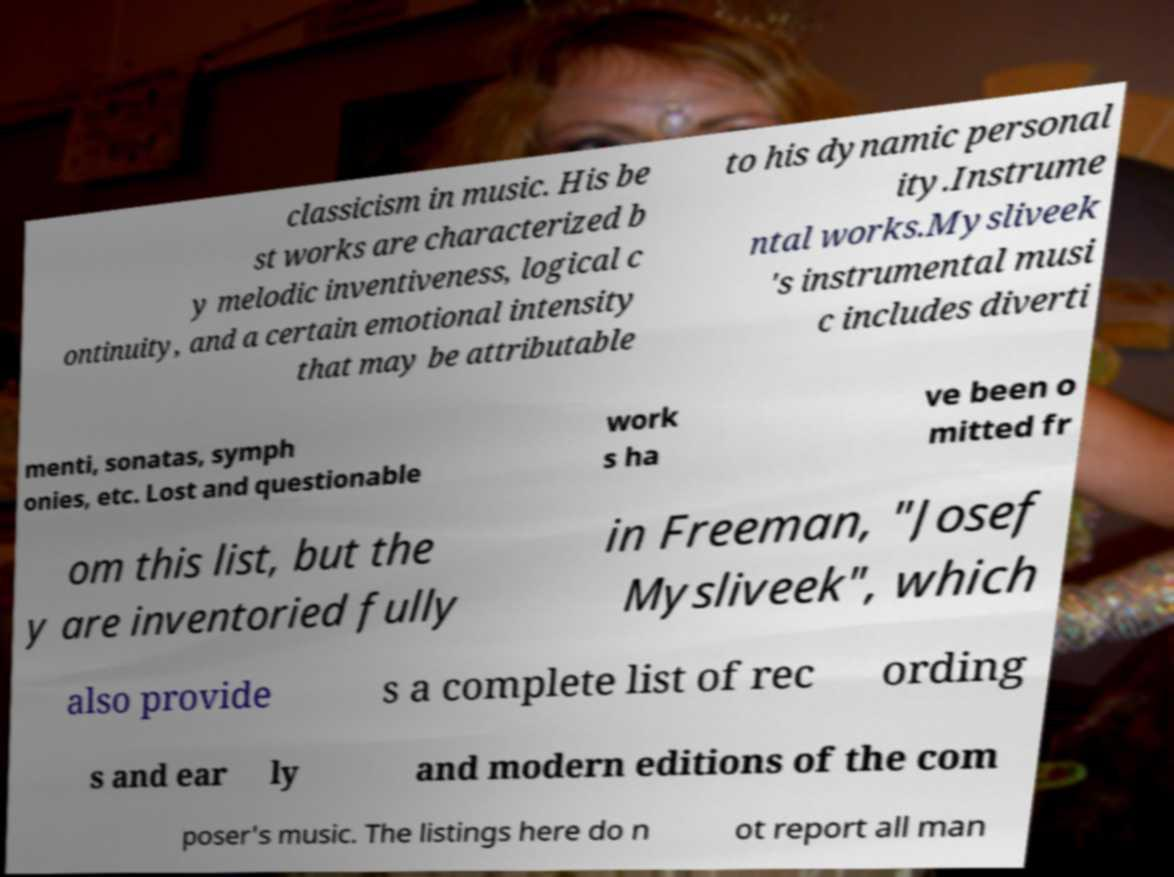Can you accurately transcribe the text from the provided image for me? classicism in music. His be st works are characterized b y melodic inventiveness, logical c ontinuity, and a certain emotional intensity that may be attributable to his dynamic personal ity.Instrume ntal works.Mysliveek 's instrumental musi c includes diverti menti, sonatas, symph onies, etc. Lost and questionable work s ha ve been o mitted fr om this list, but the y are inventoried fully in Freeman, "Josef Mysliveek", which also provide s a complete list of rec ording s and ear ly and modern editions of the com poser's music. The listings here do n ot report all man 